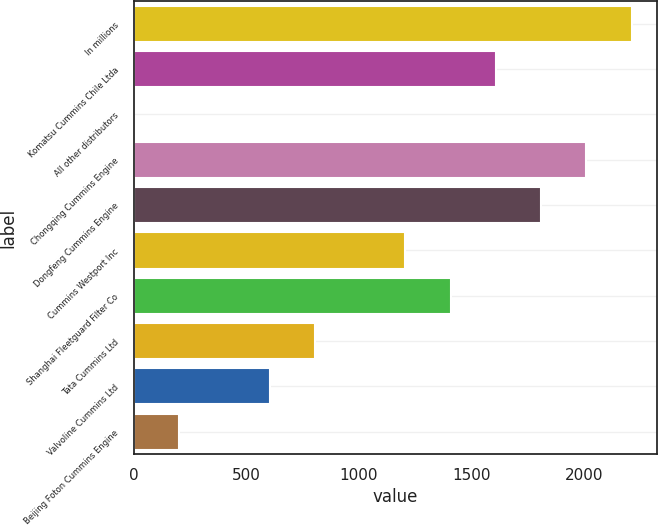Convert chart to OTSL. <chart><loc_0><loc_0><loc_500><loc_500><bar_chart><fcel>In millions<fcel>Komatsu Cummins Chile Ltda<fcel>All other distributors<fcel>Chongqing Cummins Engine<fcel>Dongfeng Cummins Engine<fcel>Cummins Westport Inc<fcel>Shanghai Fleetguard Filter Co<fcel>Tata Cummins Ltd<fcel>Valvoline Cummins Ltd<fcel>Beijing Foton Cummins Engine<nl><fcel>2213.1<fcel>1609.8<fcel>1<fcel>2012<fcel>1810.9<fcel>1207.6<fcel>1408.7<fcel>805.4<fcel>604.3<fcel>202.1<nl></chart> 